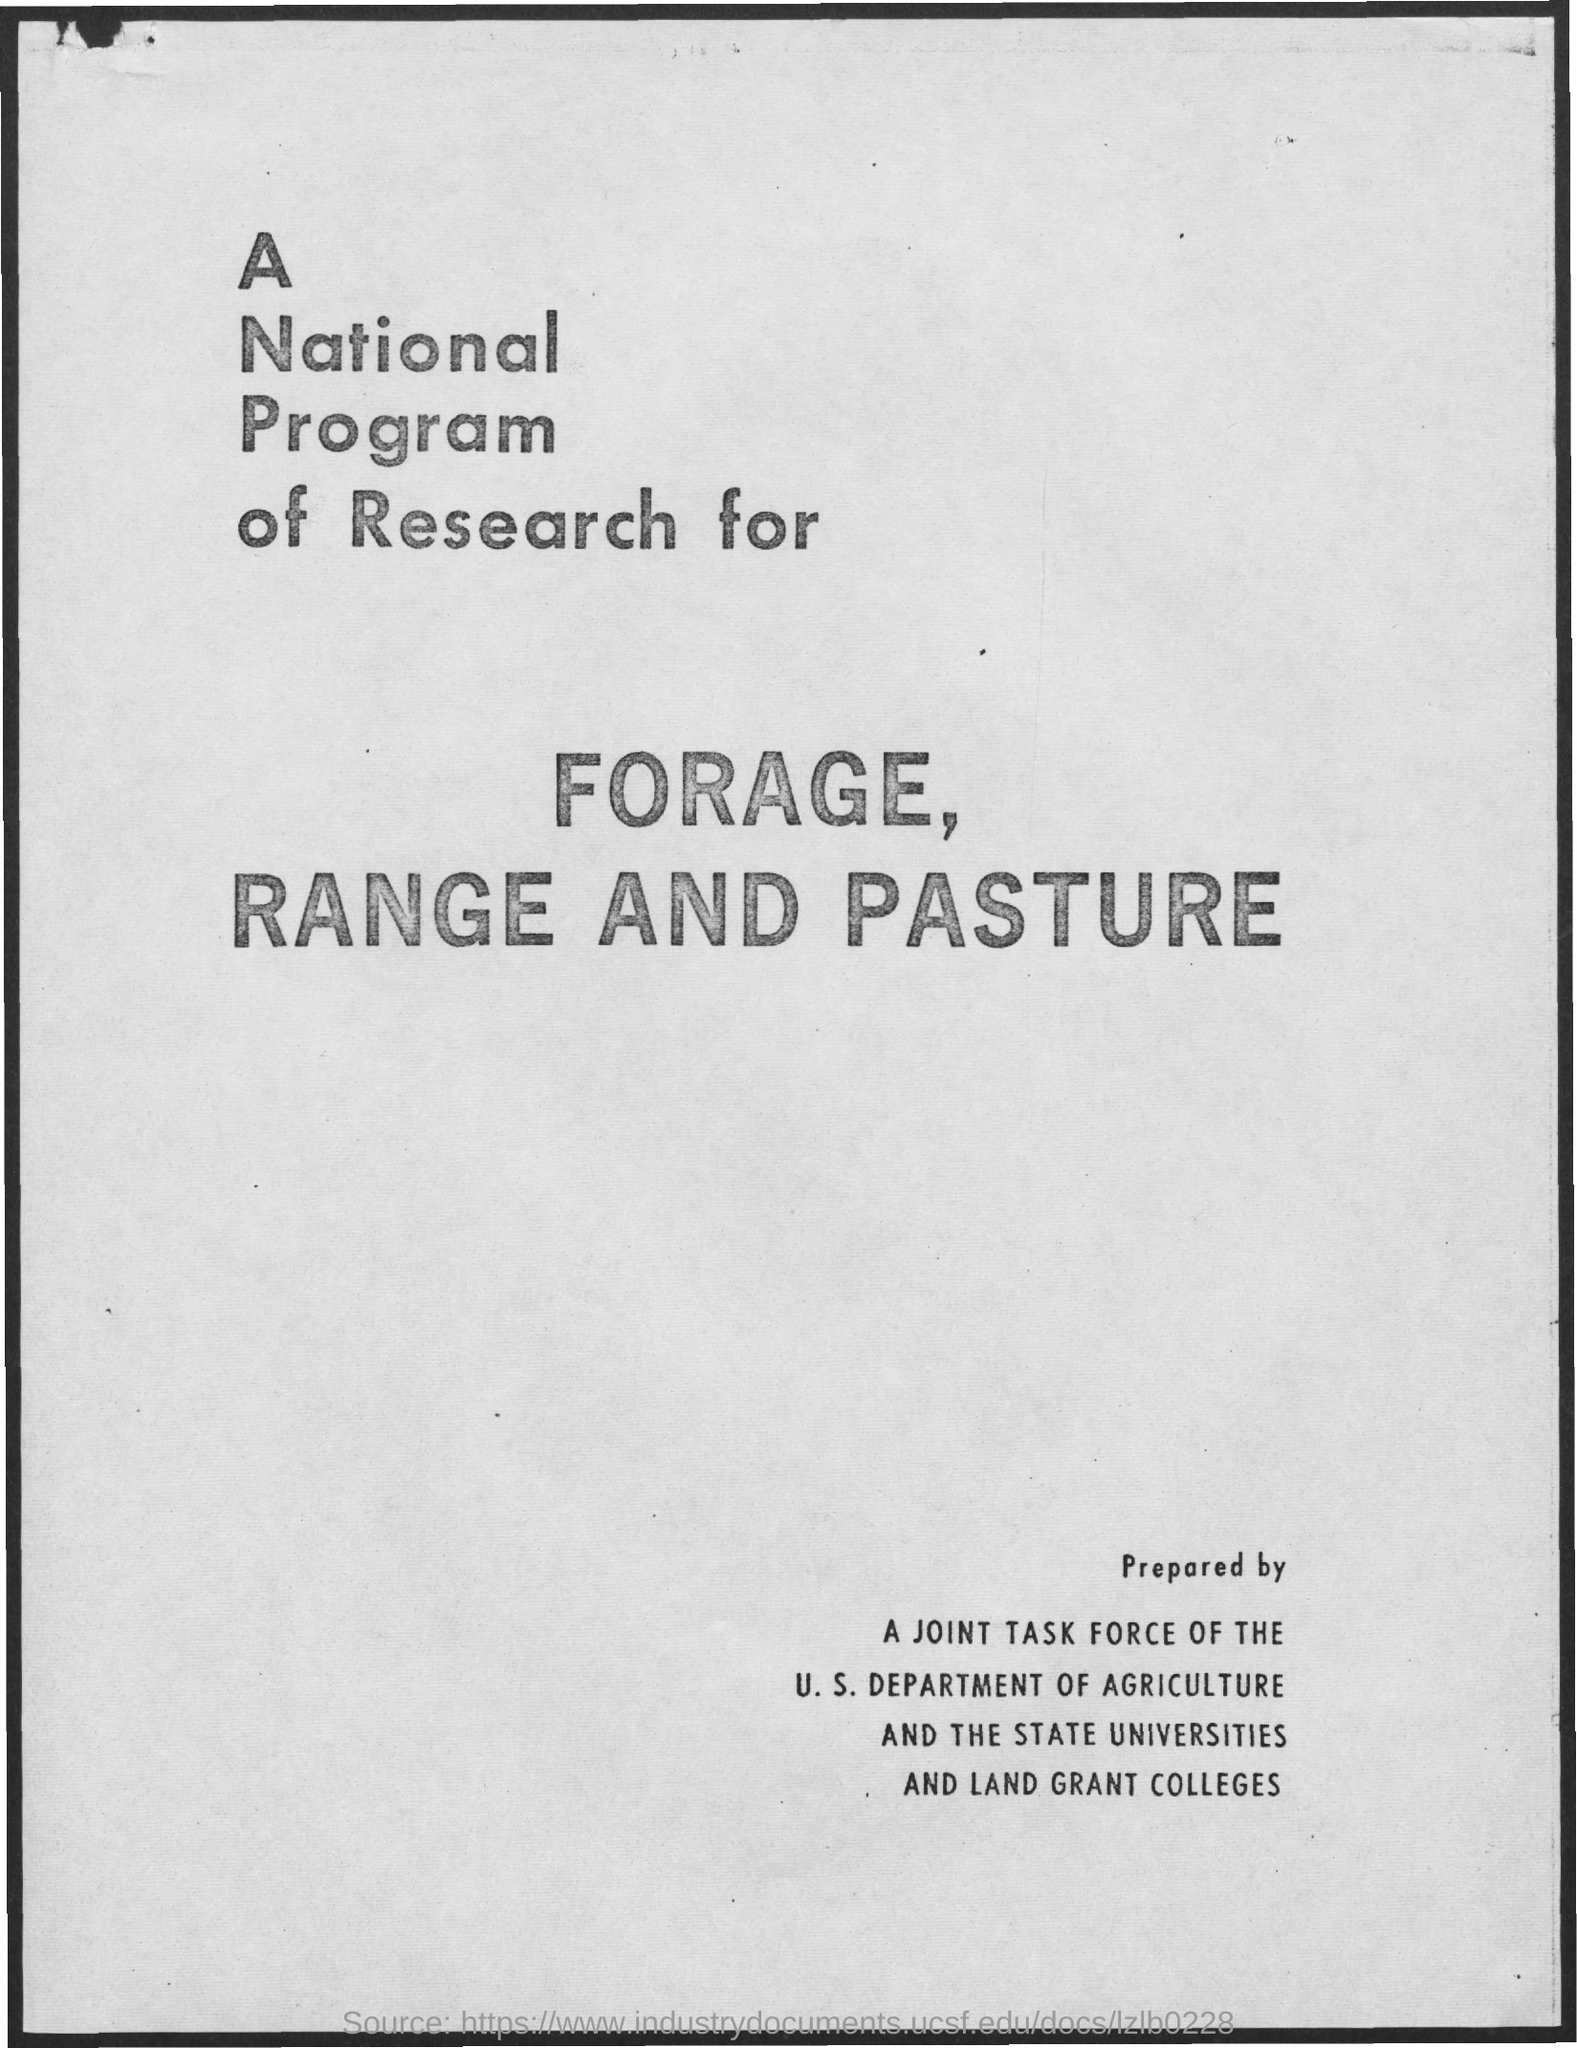What is the national program of research for?
Offer a very short reply. Forage, range and pasture. By whom is it prepared?
Offer a terse response. A joint task force of the U. S. department of agriculture and the state universities and land grant colleges. 